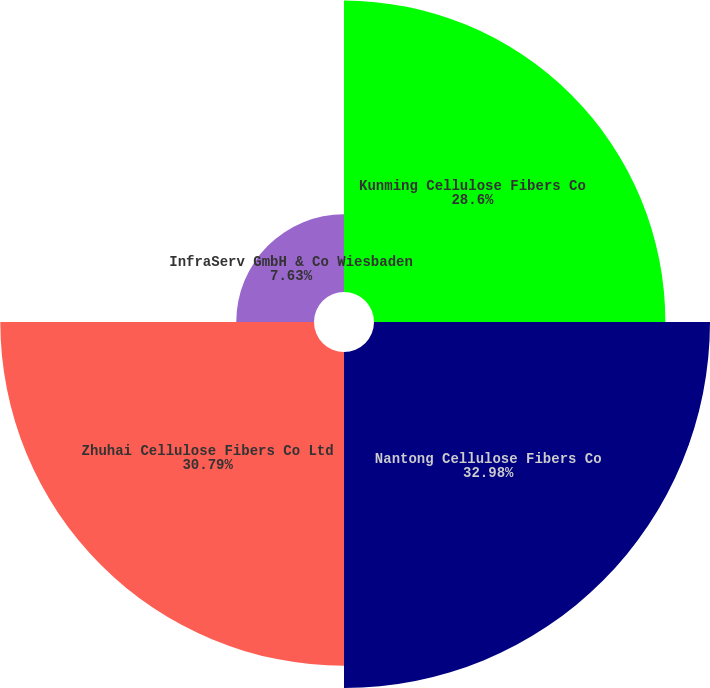<chart> <loc_0><loc_0><loc_500><loc_500><pie_chart><fcel>Kunming Cellulose Fibers Co<fcel>Nantong Cellulose Fibers Co<fcel>Zhuhai Cellulose Fibers Co Ltd<fcel>InfraServ GmbH & Co Wiesbaden<nl><fcel>28.6%<fcel>32.98%<fcel>30.79%<fcel>7.63%<nl></chart> 